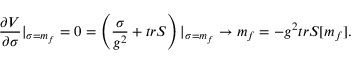Convert formula to latex. <formula><loc_0><loc_0><loc_500><loc_500>{ \frac { \partial V } { \partial \sigma } } | _ { \sigma = m _ { f } } = 0 = \left ( { \frac { \sigma } { g ^ { 2 } } } + t r S \right ) | _ { \sigma = m _ { f } } \rightarrow m _ { f } = - g ^ { 2 } t r S [ m _ { f } ] .</formula> 